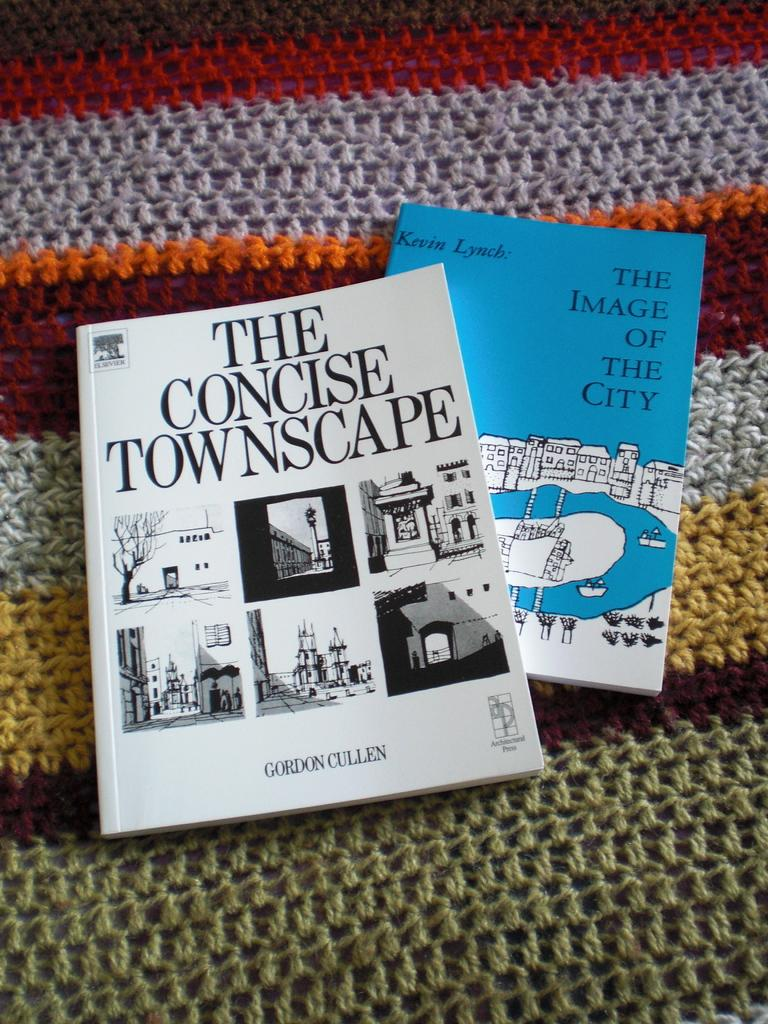<image>
Relay a brief, clear account of the picture shown. two books stacked on top of each other one titled "The Concise Townscape". 